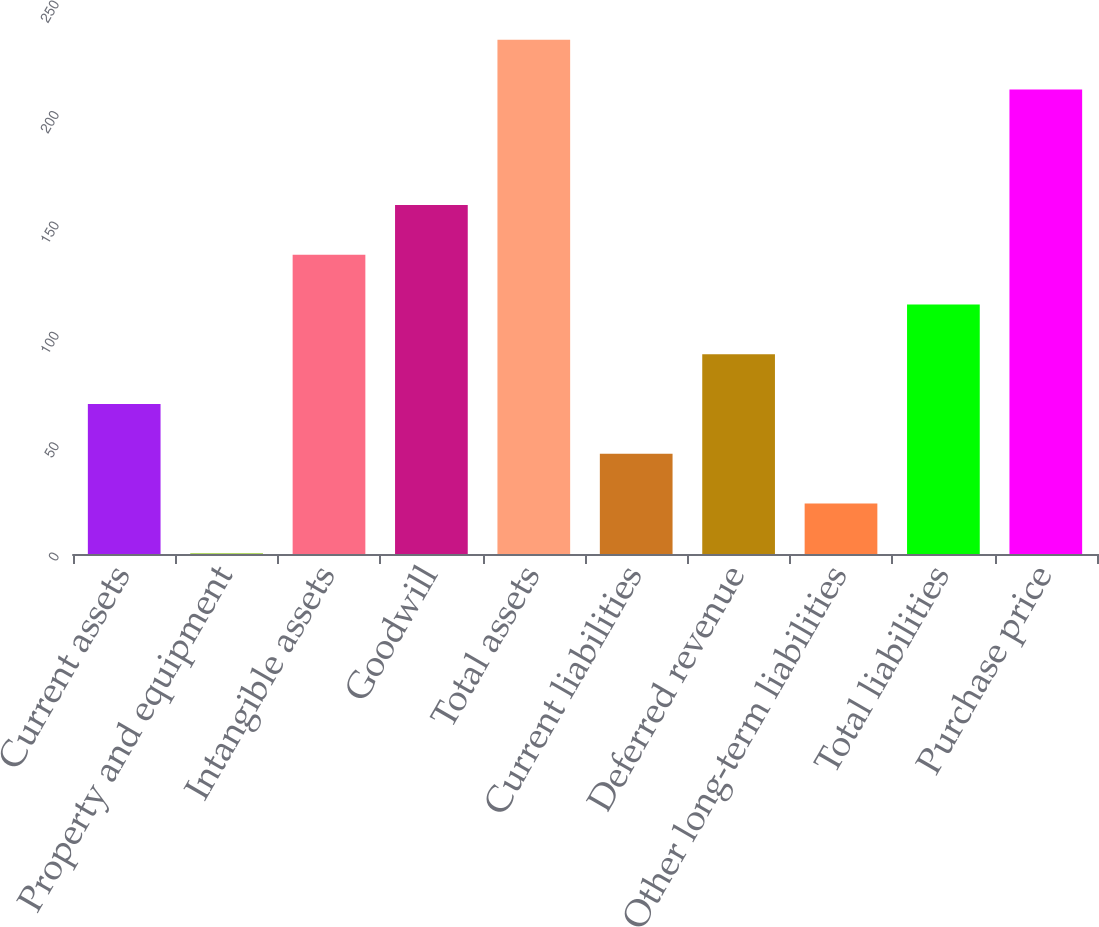<chart> <loc_0><loc_0><loc_500><loc_500><bar_chart><fcel>Current assets<fcel>Property and equipment<fcel>Intangible assets<fcel>Goodwill<fcel>Total assets<fcel>Current liabilities<fcel>Deferred revenue<fcel>Other long-term liabilities<fcel>Total liabilities<fcel>Purchase price<nl><fcel>67.92<fcel>0.3<fcel>135.54<fcel>158.08<fcel>232.94<fcel>45.38<fcel>90.46<fcel>22.84<fcel>113<fcel>210.4<nl></chart> 